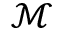Convert formula to latex. <formula><loc_0><loc_0><loc_500><loc_500>\mathcal { M }</formula> 